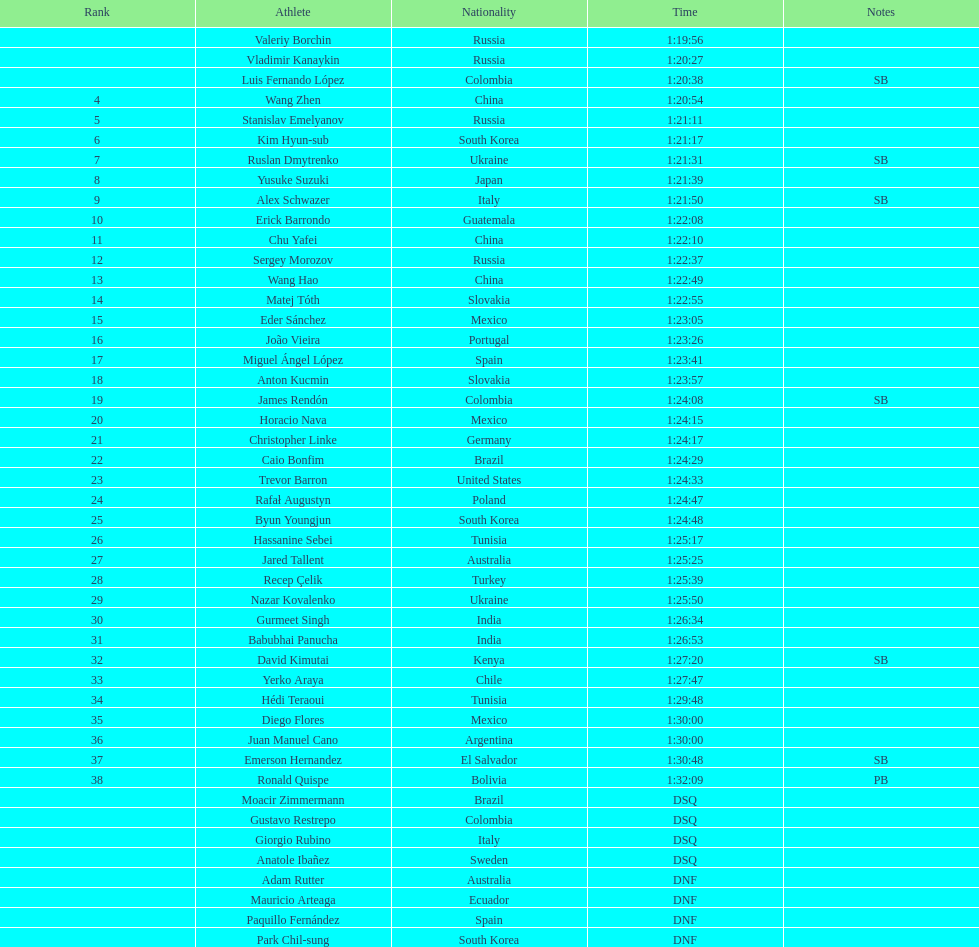Name all athletes were slower than horacio nava. Christopher Linke, Caio Bonfim, Trevor Barron, Rafał Augustyn, Byun Youngjun, Hassanine Sebei, Jared Tallent, Recep Çelik, Nazar Kovalenko, Gurmeet Singh, Babubhai Panucha, David Kimutai, Yerko Araya, Hédi Teraoui, Diego Flores, Juan Manuel Cano, Emerson Hernandez, Ronald Quispe. 